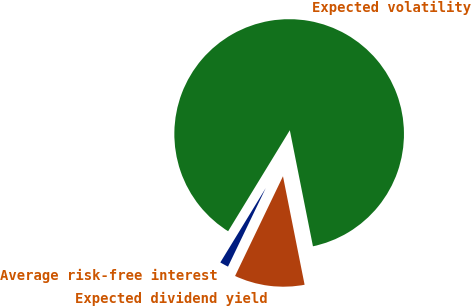Convert chart. <chart><loc_0><loc_0><loc_500><loc_500><pie_chart><fcel>Average risk-free interest<fcel>Expected dividend yield<fcel>Expected volatility<nl><fcel>1.6%<fcel>10.26%<fcel>88.14%<nl></chart> 